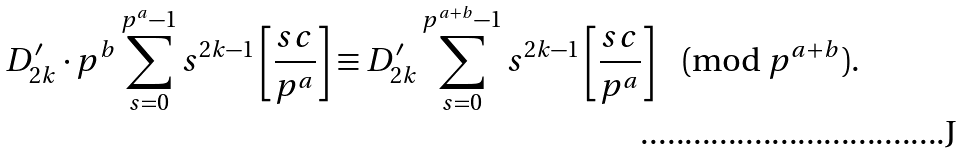<formula> <loc_0><loc_0><loc_500><loc_500>D _ { 2 k } ^ { \prime } \cdot p ^ { b } \sum _ { s = 0 } ^ { p ^ { a } - 1 } s ^ { 2 k - 1 } \left [ \frac { s c } { p ^ { a } } \right ] \equiv D _ { 2 k } ^ { \prime } \sum _ { s = 0 } ^ { p ^ { a + b } - 1 } s ^ { 2 k - 1 } \left [ \frac { s c } { p ^ { a } } \right ] \pmod { p ^ { a + b } } .</formula> 